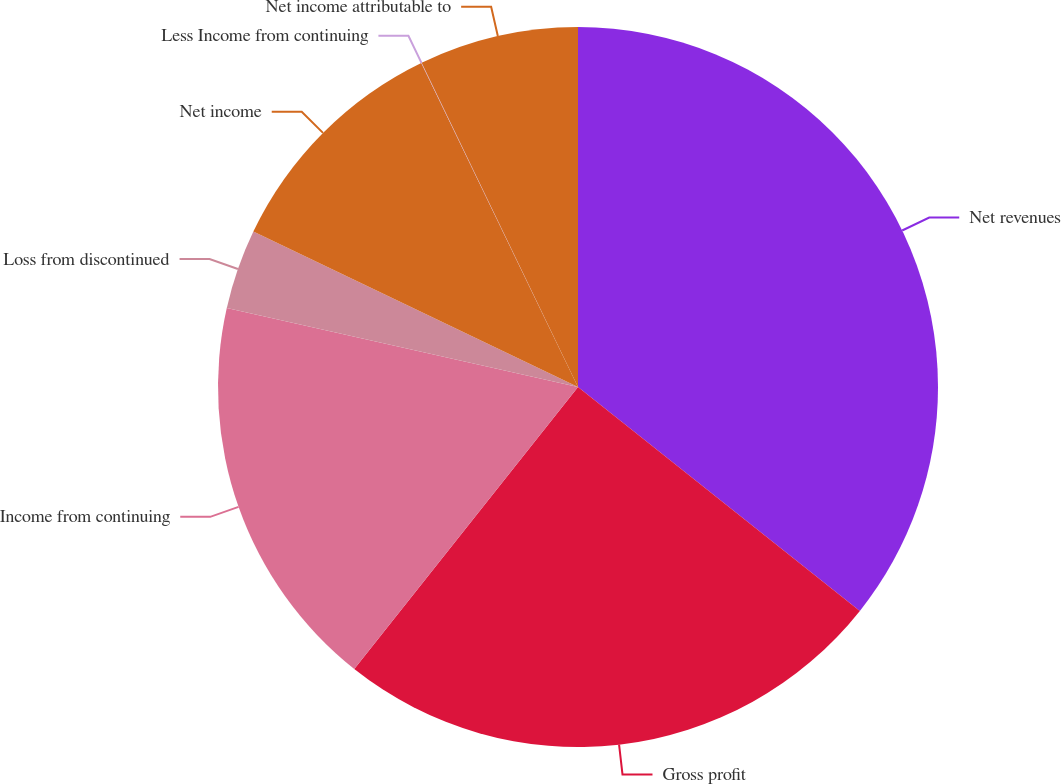<chart> <loc_0><loc_0><loc_500><loc_500><pie_chart><fcel>Net revenues<fcel>Gross profit<fcel>Income from continuing<fcel>Loss from discontinued<fcel>Net income<fcel>Less Income from continuing<fcel>Net income attributable to<nl><fcel>35.69%<fcel>24.99%<fcel>17.85%<fcel>3.59%<fcel>10.72%<fcel>0.02%<fcel>7.15%<nl></chart> 